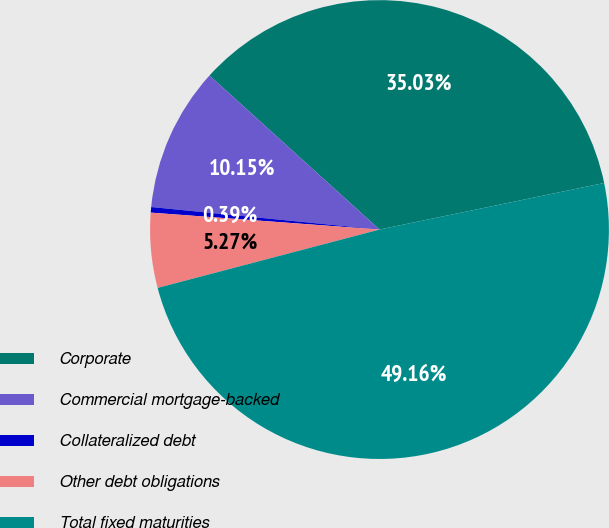Convert chart to OTSL. <chart><loc_0><loc_0><loc_500><loc_500><pie_chart><fcel>Corporate<fcel>Commercial mortgage-backed<fcel>Collateralized debt<fcel>Other debt obligations<fcel>Total fixed maturities<nl><fcel>35.03%<fcel>10.15%<fcel>0.39%<fcel>5.27%<fcel>49.16%<nl></chart> 